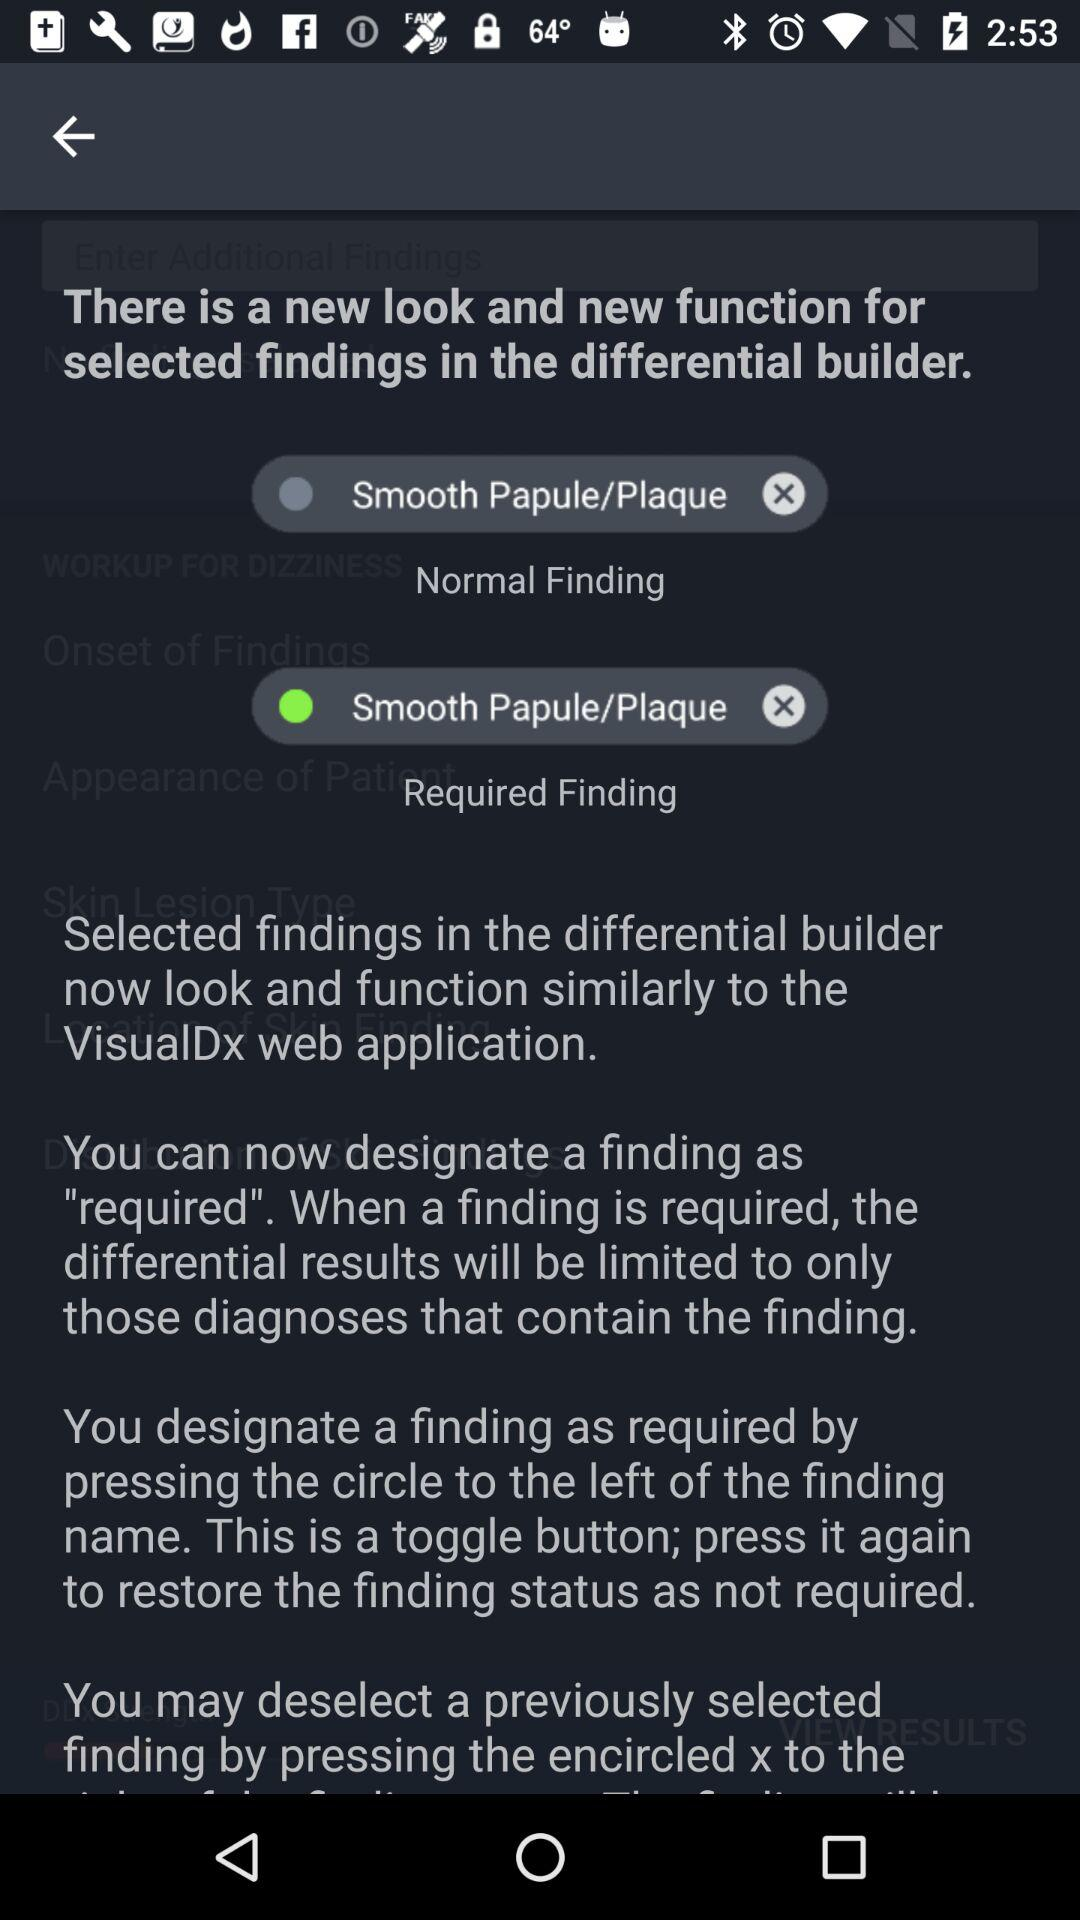How many different statuses can a finding be in?
Answer the question using a single word or phrase. 2 